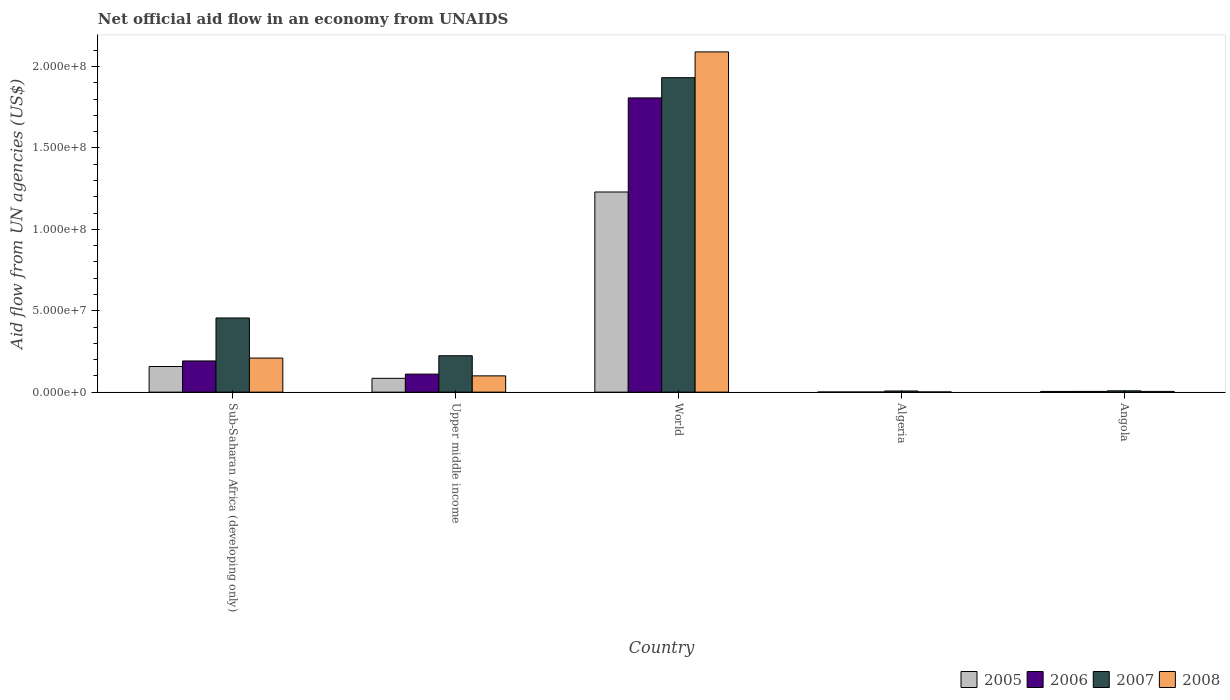How many different coloured bars are there?
Provide a short and direct response. 4. How many groups of bars are there?
Provide a succinct answer. 5. Are the number of bars per tick equal to the number of legend labels?
Keep it short and to the point. Yes. How many bars are there on the 2nd tick from the left?
Ensure brevity in your answer.  4. How many bars are there on the 4th tick from the right?
Provide a short and direct response. 4. What is the label of the 3rd group of bars from the left?
Ensure brevity in your answer.  World. In how many cases, is the number of bars for a given country not equal to the number of legend labels?
Offer a terse response. 0. What is the net official aid flow in 2006 in Sub-Saharan Africa (developing only)?
Ensure brevity in your answer.  1.92e+07. Across all countries, what is the maximum net official aid flow in 2007?
Give a very brief answer. 1.93e+08. In which country was the net official aid flow in 2006 minimum?
Make the answer very short. Algeria. What is the total net official aid flow in 2008 in the graph?
Offer a very short reply. 2.40e+08. What is the difference between the net official aid flow in 2007 in Algeria and that in Upper middle income?
Your answer should be compact. -2.16e+07. What is the difference between the net official aid flow in 2006 in Algeria and the net official aid flow in 2007 in Upper middle income?
Ensure brevity in your answer.  -2.23e+07. What is the average net official aid flow in 2006 per country?
Provide a short and direct response. 4.23e+07. What is the difference between the net official aid flow of/in 2005 and net official aid flow of/in 2007 in Angola?
Ensure brevity in your answer.  -3.80e+05. In how many countries, is the net official aid flow in 2005 greater than 200000000 US$?
Offer a terse response. 0. What is the ratio of the net official aid flow in 2007 in Sub-Saharan Africa (developing only) to that in World?
Make the answer very short. 0.24. What is the difference between the highest and the second highest net official aid flow in 2005?
Your answer should be very brief. 1.14e+08. What is the difference between the highest and the lowest net official aid flow in 2008?
Give a very brief answer. 2.09e+08. Is it the case that in every country, the sum of the net official aid flow in 2008 and net official aid flow in 2006 is greater than the sum of net official aid flow in 2007 and net official aid flow in 2005?
Ensure brevity in your answer.  No. How many bars are there?
Keep it short and to the point. 20. Are all the bars in the graph horizontal?
Your answer should be very brief. No. How many countries are there in the graph?
Provide a succinct answer. 5. Are the values on the major ticks of Y-axis written in scientific E-notation?
Give a very brief answer. Yes. Does the graph contain grids?
Your answer should be very brief. No. Where does the legend appear in the graph?
Keep it short and to the point. Bottom right. How are the legend labels stacked?
Provide a succinct answer. Horizontal. What is the title of the graph?
Ensure brevity in your answer.  Net official aid flow in an economy from UNAIDS. What is the label or title of the X-axis?
Provide a succinct answer. Country. What is the label or title of the Y-axis?
Provide a succinct answer. Aid flow from UN agencies (US$). What is the Aid flow from UN agencies (US$) of 2005 in Sub-Saharan Africa (developing only)?
Keep it short and to the point. 1.58e+07. What is the Aid flow from UN agencies (US$) of 2006 in Sub-Saharan Africa (developing only)?
Make the answer very short. 1.92e+07. What is the Aid flow from UN agencies (US$) in 2007 in Sub-Saharan Africa (developing only)?
Your answer should be compact. 4.56e+07. What is the Aid flow from UN agencies (US$) of 2008 in Sub-Saharan Africa (developing only)?
Offer a very short reply. 2.09e+07. What is the Aid flow from UN agencies (US$) of 2005 in Upper middle income?
Keep it short and to the point. 8.49e+06. What is the Aid flow from UN agencies (US$) in 2006 in Upper middle income?
Your answer should be very brief. 1.11e+07. What is the Aid flow from UN agencies (US$) in 2007 in Upper middle income?
Make the answer very short. 2.24e+07. What is the Aid flow from UN agencies (US$) in 2008 in Upper middle income?
Make the answer very short. 1.00e+07. What is the Aid flow from UN agencies (US$) of 2005 in World?
Give a very brief answer. 1.23e+08. What is the Aid flow from UN agencies (US$) of 2006 in World?
Offer a terse response. 1.81e+08. What is the Aid flow from UN agencies (US$) in 2007 in World?
Provide a short and direct response. 1.93e+08. What is the Aid flow from UN agencies (US$) of 2008 in World?
Provide a short and direct response. 2.09e+08. What is the Aid flow from UN agencies (US$) in 2005 in Algeria?
Your answer should be very brief. 9.00e+04. What is the Aid flow from UN agencies (US$) of 2007 in Algeria?
Keep it short and to the point. 7.10e+05. What is the Aid flow from UN agencies (US$) of 2005 in Angola?
Give a very brief answer. 4.30e+05. What is the Aid flow from UN agencies (US$) in 2007 in Angola?
Offer a very short reply. 8.10e+05. What is the Aid flow from UN agencies (US$) in 2008 in Angola?
Your response must be concise. 4.60e+05. Across all countries, what is the maximum Aid flow from UN agencies (US$) of 2005?
Provide a short and direct response. 1.23e+08. Across all countries, what is the maximum Aid flow from UN agencies (US$) in 2006?
Offer a terse response. 1.81e+08. Across all countries, what is the maximum Aid flow from UN agencies (US$) in 2007?
Your response must be concise. 1.93e+08. Across all countries, what is the maximum Aid flow from UN agencies (US$) in 2008?
Make the answer very short. 2.09e+08. Across all countries, what is the minimum Aid flow from UN agencies (US$) in 2006?
Offer a terse response. 9.00e+04. Across all countries, what is the minimum Aid flow from UN agencies (US$) in 2007?
Provide a short and direct response. 7.10e+05. What is the total Aid flow from UN agencies (US$) in 2005 in the graph?
Give a very brief answer. 1.48e+08. What is the total Aid flow from UN agencies (US$) of 2006 in the graph?
Provide a short and direct response. 2.11e+08. What is the total Aid flow from UN agencies (US$) in 2007 in the graph?
Your response must be concise. 2.63e+08. What is the total Aid flow from UN agencies (US$) of 2008 in the graph?
Provide a short and direct response. 2.40e+08. What is the difference between the Aid flow from UN agencies (US$) in 2005 in Sub-Saharan Africa (developing only) and that in Upper middle income?
Provide a succinct answer. 7.26e+06. What is the difference between the Aid flow from UN agencies (US$) of 2006 in Sub-Saharan Africa (developing only) and that in Upper middle income?
Your response must be concise. 8.08e+06. What is the difference between the Aid flow from UN agencies (US$) of 2007 in Sub-Saharan Africa (developing only) and that in Upper middle income?
Provide a short and direct response. 2.32e+07. What is the difference between the Aid flow from UN agencies (US$) in 2008 in Sub-Saharan Africa (developing only) and that in Upper middle income?
Your answer should be compact. 1.09e+07. What is the difference between the Aid flow from UN agencies (US$) of 2005 in Sub-Saharan Africa (developing only) and that in World?
Your response must be concise. -1.07e+08. What is the difference between the Aid flow from UN agencies (US$) of 2006 in Sub-Saharan Africa (developing only) and that in World?
Offer a very short reply. -1.62e+08. What is the difference between the Aid flow from UN agencies (US$) in 2007 in Sub-Saharan Africa (developing only) and that in World?
Give a very brief answer. -1.48e+08. What is the difference between the Aid flow from UN agencies (US$) of 2008 in Sub-Saharan Africa (developing only) and that in World?
Give a very brief answer. -1.88e+08. What is the difference between the Aid flow from UN agencies (US$) in 2005 in Sub-Saharan Africa (developing only) and that in Algeria?
Offer a terse response. 1.57e+07. What is the difference between the Aid flow from UN agencies (US$) of 2006 in Sub-Saharan Africa (developing only) and that in Algeria?
Your answer should be compact. 1.91e+07. What is the difference between the Aid flow from UN agencies (US$) of 2007 in Sub-Saharan Africa (developing only) and that in Algeria?
Your response must be concise. 4.48e+07. What is the difference between the Aid flow from UN agencies (US$) in 2008 in Sub-Saharan Africa (developing only) and that in Algeria?
Provide a succinct answer. 2.08e+07. What is the difference between the Aid flow from UN agencies (US$) in 2005 in Sub-Saharan Africa (developing only) and that in Angola?
Your answer should be compact. 1.53e+07. What is the difference between the Aid flow from UN agencies (US$) of 2006 in Sub-Saharan Africa (developing only) and that in Angola?
Your answer should be compact. 1.87e+07. What is the difference between the Aid flow from UN agencies (US$) of 2007 in Sub-Saharan Africa (developing only) and that in Angola?
Provide a succinct answer. 4.47e+07. What is the difference between the Aid flow from UN agencies (US$) in 2008 in Sub-Saharan Africa (developing only) and that in Angola?
Offer a very short reply. 2.05e+07. What is the difference between the Aid flow from UN agencies (US$) in 2005 in Upper middle income and that in World?
Your response must be concise. -1.14e+08. What is the difference between the Aid flow from UN agencies (US$) of 2006 in Upper middle income and that in World?
Your answer should be compact. -1.70e+08. What is the difference between the Aid flow from UN agencies (US$) in 2007 in Upper middle income and that in World?
Provide a succinct answer. -1.71e+08. What is the difference between the Aid flow from UN agencies (US$) in 2008 in Upper middle income and that in World?
Make the answer very short. -1.99e+08. What is the difference between the Aid flow from UN agencies (US$) in 2005 in Upper middle income and that in Algeria?
Offer a very short reply. 8.40e+06. What is the difference between the Aid flow from UN agencies (US$) of 2006 in Upper middle income and that in Algeria?
Your answer should be compact. 1.10e+07. What is the difference between the Aid flow from UN agencies (US$) of 2007 in Upper middle income and that in Algeria?
Your response must be concise. 2.16e+07. What is the difference between the Aid flow from UN agencies (US$) of 2008 in Upper middle income and that in Algeria?
Offer a very short reply. 9.87e+06. What is the difference between the Aid flow from UN agencies (US$) of 2005 in Upper middle income and that in Angola?
Your answer should be compact. 8.06e+06. What is the difference between the Aid flow from UN agencies (US$) of 2006 in Upper middle income and that in Angola?
Make the answer very short. 1.06e+07. What is the difference between the Aid flow from UN agencies (US$) of 2007 in Upper middle income and that in Angola?
Your answer should be compact. 2.16e+07. What is the difference between the Aid flow from UN agencies (US$) of 2008 in Upper middle income and that in Angola?
Provide a succinct answer. 9.54e+06. What is the difference between the Aid flow from UN agencies (US$) in 2005 in World and that in Algeria?
Your answer should be very brief. 1.23e+08. What is the difference between the Aid flow from UN agencies (US$) in 2006 in World and that in Algeria?
Ensure brevity in your answer.  1.81e+08. What is the difference between the Aid flow from UN agencies (US$) in 2007 in World and that in Algeria?
Offer a terse response. 1.92e+08. What is the difference between the Aid flow from UN agencies (US$) in 2008 in World and that in Algeria?
Give a very brief answer. 2.09e+08. What is the difference between the Aid flow from UN agencies (US$) of 2005 in World and that in Angola?
Offer a terse response. 1.22e+08. What is the difference between the Aid flow from UN agencies (US$) of 2006 in World and that in Angola?
Provide a succinct answer. 1.80e+08. What is the difference between the Aid flow from UN agencies (US$) of 2007 in World and that in Angola?
Make the answer very short. 1.92e+08. What is the difference between the Aid flow from UN agencies (US$) in 2008 in World and that in Angola?
Make the answer very short. 2.08e+08. What is the difference between the Aid flow from UN agencies (US$) in 2006 in Algeria and that in Angola?
Offer a very short reply. -3.60e+05. What is the difference between the Aid flow from UN agencies (US$) of 2008 in Algeria and that in Angola?
Your answer should be very brief. -3.30e+05. What is the difference between the Aid flow from UN agencies (US$) of 2005 in Sub-Saharan Africa (developing only) and the Aid flow from UN agencies (US$) of 2006 in Upper middle income?
Your answer should be very brief. 4.67e+06. What is the difference between the Aid flow from UN agencies (US$) in 2005 in Sub-Saharan Africa (developing only) and the Aid flow from UN agencies (US$) in 2007 in Upper middle income?
Your response must be concise. -6.61e+06. What is the difference between the Aid flow from UN agencies (US$) in 2005 in Sub-Saharan Africa (developing only) and the Aid flow from UN agencies (US$) in 2008 in Upper middle income?
Provide a succinct answer. 5.75e+06. What is the difference between the Aid flow from UN agencies (US$) in 2006 in Sub-Saharan Africa (developing only) and the Aid flow from UN agencies (US$) in 2007 in Upper middle income?
Offer a terse response. -3.20e+06. What is the difference between the Aid flow from UN agencies (US$) in 2006 in Sub-Saharan Africa (developing only) and the Aid flow from UN agencies (US$) in 2008 in Upper middle income?
Make the answer very short. 9.16e+06. What is the difference between the Aid flow from UN agencies (US$) of 2007 in Sub-Saharan Africa (developing only) and the Aid flow from UN agencies (US$) of 2008 in Upper middle income?
Your answer should be compact. 3.56e+07. What is the difference between the Aid flow from UN agencies (US$) in 2005 in Sub-Saharan Africa (developing only) and the Aid flow from UN agencies (US$) in 2006 in World?
Provide a short and direct response. -1.65e+08. What is the difference between the Aid flow from UN agencies (US$) in 2005 in Sub-Saharan Africa (developing only) and the Aid flow from UN agencies (US$) in 2007 in World?
Your response must be concise. -1.77e+08. What is the difference between the Aid flow from UN agencies (US$) in 2005 in Sub-Saharan Africa (developing only) and the Aid flow from UN agencies (US$) in 2008 in World?
Make the answer very short. -1.93e+08. What is the difference between the Aid flow from UN agencies (US$) of 2006 in Sub-Saharan Africa (developing only) and the Aid flow from UN agencies (US$) of 2007 in World?
Offer a terse response. -1.74e+08. What is the difference between the Aid flow from UN agencies (US$) of 2006 in Sub-Saharan Africa (developing only) and the Aid flow from UN agencies (US$) of 2008 in World?
Provide a short and direct response. -1.90e+08. What is the difference between the Aid flow from UN agencies (US$) of 2007 in Sub-Saharan Africa (developing only) and the Aid flow from UN agencies (US$) of 2008 in World?
Keep it short and to the point. -1.63e+08. What is the difference between the Aid flow from UN agencies (US$) of 2005 in Sub-Saharan Africa (developing only) and the Aid flow from UN agencies (US$) of 2006 in Algeria?
Offer a very short reply. 1.57e+07. What is the difference between the Aid flow from UN agencies (US$) of 2005 in Sub-Saharan Africa (developing only) and the Aid flow from UN agencies (US$) of 2007 in Algeria?
Your answer should be compact. 1.50e+07. What is the difference between the Aid flow from UN agencies (US$) of 2005 in Sub-Saharan Africa (developing only) and the Aid flow from UN agencies (US$) of 2008 in Algeria?
Give a very brief answer. 1.56e+07. What is the difference between the Aid flow from UN agencies (US$) in 2006 in Sub-Saharan Africa (developing only) and the Aid flow from UN agencies (US$) in 2007 in Algeria?
Offer a very short reply. 1.84e+07. What is the difference between the Aid flow from UN agencies (US$) of 2006 in Sub-Saharan Africa (developing only) and the Aid flow from UN agencies (US$) of 2008 in Algeria?
Give a very brief answer. 1.90e+07. What is the difference between the Aid flow from UN agencies (US$) in 2007 in Sub-Saharan Africa (developing only) and the Aid flow from UN agencies (US$) in 2008 in Algeria?
Ensure brevity in your answer.  4.54e+07. What is the difference between the Aid flow from UN agencies (US$) of 2005 in Sub-Saharan Africa (developing only) and the Aid flow from UN agencies (US$) of 2006 in Angola?
Provide a short and direct response. 1.53e+07. What is the difference between the Aid flow from UN agencies (US$) of 2005 in Sub-Saharan Africa (developing only) and the Aid flow from UN agencies (US$) of 2007 in Angola?
Provide a short and direct response. 1.49e+07. What is the difference between the Aid flow from UN agencies (US$) in 2005 in Sub-Saharan Africa (developing only) and the Aid flow from UN agencies (US$) in 2008 in Angola?
Provide a succinct answer. 1.53e+07. What is the difference between the Aid flow from UN agencies (US$) in 2006 in Sub-Saharan Africa (developing only) and the Aid flow from UN agencies (US$) in 2007 in Angola?
Offer a very short reply. 1.84e+07. What is the difference between the Aid flow from UN agencies (US$) in 2006 in Sub-Saharan Africa (developing only) and the Aid flow from UN agencies (US$) in 2008 in Angola?
Make the answer very short. 1.87e+07. What is the difference between the Aid flow from UN agencies (US$) of 2007 in Sub-Saharan Africa (developing only) and the Aid flow from UN agencies (US$) of 2008 in Angola?
Give a very brief answer. 4.51e+07. What is the difference between the Aid flow from UN agencies (US$) in 2005 in Upper middle income and the Aid flow from UN agencies (US$) in 2006 in World?
Your answer should be compact. -1.72e+08. What is the difference between the Aid flow from UN agencies (US$) in 2005 in Upper middle income and the Aid flow from UN agencies (US$) in 2007 in World?
Offer a very short reply. -1.85e+08. What is the difference between the Aid flow from UN agencies (US$) in 2005 in Upper middle income and the Aid flow from UN agencies (US$) in 2008 in World?
Ensure brevity in your answer.  -2.00e+08. What is the difference between the Aid flow from UN agencies (US$) of 2006 in Upper middle income and the Aid flow from UN agencies (US$) of 2007 in World?
Give a very brief answer. -1.82e+08. What is the difference between the Aid flow from UN agencies (US$) of 2006 in Upper middle income and the Aid flow from UN agencies (US$) of 2008 in World?
Make the answer very short. -1.98e+08. What is the difference between the Aid flow from UN agencies (US$) of 2007 in Upper middle income and the Aid flow from UN agencies (US$) of 2008 in World?
Keep it short and to the point. -1.87e+08. What is the difference between the Aid flow from UN agencies (US$) in 2005 in Upper middle income and the Aid flow from UN agencies (US$) in 2006 in Algeria?
Make the answer very short. 8.40e+06. What is the difference between the Aid flow from UN agencies (US$) in 2005 in Upper middle income and the Aid flow from UN agencies (US$) in 2007 in Algeria?
Your answer should be compact. 7.78e+06. What is the difference between the Aid flow from UN agencies (US$) in 2005 in Upper middle income and the Aid flow from UN agencies (US$) in 2008 in Algeria?
Your answer should be compact. 8.36e+06. What is the difference between the Aid flow from UN agencies (US$) of 2006 in Upper middle income and the Aid flow from UN agencies (US$) of 2007 in Algeria?
Your answer should be compact. 1.04e+07. What is the difference between the Aid flow from UN agencies (US$) in 2006 in Upper middle income and the Aid flow from UN agencies (US$) in 2008 in Algeria?
Your answer should be very brief. 1.10e+07. What is the difference between the Aid flow from UN agencies (US$) in 2007 in Upper middle income and the Aid flow from UN agencies (US$) in 2008 in Algeria?
Provide a short and direct response. 2.22e+07. What is the difference between the Aid flow from UN agencies (US$) in 2005 in Upper middle income and the Aid flow from UN agencies (US$) in 2006 in Angola?
Make the answer very short. 8.04e+06. What is the difference between the Aid flow from UN agencies (US$) of 2005 in Upper middle income and the Aid flow from UN agencies (US$) of 2007 in Angola?
Your answer should be very brief. 7.68e+06. What is the difference between the Aid flow from UN agencies (US$) in 2005 in Upper middle income and the Aid flow from UN agencies (US$) in 2008 in Angola?
Ensure brevity in your answer.  8.03e+06. What is the difference between the Aid flow from UN agencies (US$) in 2006 in Upper middle income and the Aid flow from UN agencies (US$) in 2007 in Angola?
Provide a short and direct response. 1.03e+07. What is the difference between the Aid flow from UN agencies (US$) of 2006 in Upper middle income and the Aid flow from UN agencies (US$) of 2008 in Angola?
Ensure brevity in your answer.  1.06e+07. What is the difference between the Aid flow from UN agencies (US$) in 2007 in Upper middle income and the Aid flow from UN agencies (US$) in 2008 in Angola?
Make the answer very short. 2.19e+07. What is the difference between the Aid flow from UN agencies (US$) in 2005 in World and the Aid flow from UN agencies (US$) in 2006 in Algeria?
Your answer should be very brief. 1.23e+08. What is the difference between the Aid flow from UN agencies (US$) in 2005 in World and the Aid flow from UN agencies (US$) in 2007 in Algeria?
Offer a very short reply. 1.22e+08. What is the difference between the Aid flow from UN agencies (US$) in 2005 in World and the Aid flow from UN agencies (US$) in 2008 in Algeria?
Offer a very short reply. 1.23e+08. What is the difference between the Aid flow from UN agencies (US$) of 2006 in World and the Aid flow from UN agencies (US$) of 2007 in Algeria?
Your answer should be very brief. 1.80e+08. What is the difference between the Aid flow from UN agencies (US$) in 2006 in World and the Aid flow from UN agencies (US$) in 2008 in Algeria?
Provide a succinct answer. 1.81e+08. What is the difference between the Aid flow from UN agencies (US$) of 2007 in World and the Aid flow from UN agencies (US$) of 2008 in Algeria?
Offer a very short reply. 1.93e+08. What is the difference between the Aid flow from UN agencies (US$) of 2005 in World and the Aid flow from UN agencies (US$) of 2006 in Angola?
Provide a succinct answer. 1.22e+08. What is the difference between the Aid flow from UN agencies (US$) in 2005 in World and the Aid flow from UN agencies (US$) in 2007 in Angola?
Provide a short and direct response. 1.22e+08. What is the difference between the Aid flow from UN agencies (US$) in 2005 in World and the Aid flow from UN agencies (US$) in 2008 in Angola?
Your answer should be very brief. 1.22e+08. What is the difference between the Aid flow from UN agencies (US$) in 2006 in World and the Aid flow from UN agencies (US$) in 2007 in Angola?
Offer a terse response. 1.80e+08. What is the difference between the Aid flow from UN agencies (US$) of 2006 in World and the Aid flow from UN agencies (US$) of 2008 in Angola?
Ensure brevity in your answer.  1.80e+08. What is the difference between the Aid flow from UN agencies (US$) in 2007 in World and the Aid flow from UN agencies (US$) in 2008 in Angola?
Provide a short and direct response. 1.93e+08. What is the difference between the Aid flow from UN agencies (US$) of 2005 in Algeria and the Aid flow from UN agencies (US$) of 2006 in Angola?
Give a very brief answer. -3.60e+05. What is the difference between the Aid flow from UN agencies (US$) of 2005 in Algeria and the Aid flow from UN agencies (US$) of 2007 in Angola?
Make the answer very short. -7.20e+05. What is the difference between the Aid flow from UN agencies (US$) of 2005 in Algeria and the Aid flow from UN agencies (US$) of 2008 in Angola?
Keep it short and to the point. -3.70e+05. What is the difference between the Aid flow from UN agencies (US$) in 2006 in Algeria and the Aid flow from UN agencies (US$) in 2007 in Angola?
Your response must be concise. -7.20e+05. What is the difference between the Aid flow from UN agencies (US$) of 2006 in Algeria and the Aid flow from UN agencies (US$) of 2008 in Angola?
Provide a short and direct response. -3.70e+05. What is the difference between the Aid flow from UN agencies (US$) in 2007 in Algeria and the Aid flow from UN agencies (US$) in 2008 in Angola?
Provide a succinct answer. 2.50e+05. What is the average Aid flow from UN agencies (US$) in 2005 per country?
Provide a succinct answer. 2.95e+07. What is the average Aid flow from UN agencies (US$) in 2006 per country?
Offer a terse response. 4.23e+07. What is the average Aid flow from UN agencies (US$) of 2007 per country?
Your answer should be compact. 5.25e+07. What is the average Aid flow from UN agencies (US$) of 2008 per country?
Provide a succinct answer. 4.81e+07. What is the difference between the Aid flow from UN agencies (US$) of 2005 and Aid flow from UN agencies (US$) of 2006 in Sub-Saharan Africa (developing only)?
Your response must be concise. -3.41e+06. What is the difference between the Aid flow from UN agencies (US$) in 2005 and Aid flow from UN agencies (US$) in 2007 in Sub-Saharan Africa (developing only)?
Offer a very short reply. -2.98e+07. What is the difference between the Aid flow from UN agencies (US$) in 2005 and Aid flow from UN agencies (US$) in 2008 in Sub-Saharan Africa (developing only)?
Offer a terse response. -5.18e+06. What is the difference between the Aid flow from UN agencies (US$) of 2006 and Aid flow from UN agencies (US$) of 2007 in Sub-Saharan Africa (developing only)?
Make the answer very short. -2.64e+07. What is the difference between the Aid flow from UN agencies (US$) in 2006 and Aid flow from UN agencies (US$) in 2008 in Sub-Saharan Africa (developing only)?
Provide a short and direct response. -1.77e+06. What is the difference between the Aid flow from UN agencies (US$) in 2007 and Aid flow from UN agencies (US$) in 2008 in Sub-Saharan Africa (developing only)?
Give a very brief answer. 2.46e+07. What is the difference between the Aid flow from UN agencies (US$) in 2005 and Aid flow from UN agencies (US$) in 2006 in Upper middle income?
Provide a short and direct response. -2.59e+06. What is the difference between the Aid flow from UN agencies (US$) of 2005 and Aid flow from UN agencies (US$) of 2007 in Upper middle income?
Provide a short and direct response. -1.39e+07. What is the difference between the Aid flow from UN agencies (US$) in 2005 and Aid flow from UN agencies (US$) in 2008 in Upper middle income?
Ensure brevity in your answer.  -1.51e+06. What is the difference between the Aid flow from UN agencies (US$) of 2006 and Aid flow from UN agencies (US$) of 2007 in Upper middle income?
Ensure brevity in your answer.  -1.13e+07. What is the difference between the Aid flow from UN agencies (US$) of 2006 and Aid flow from UN agencies (US$) of 2008 in Upper middle income?
Give a very brief answer. 1.08e+06. What is the difference between the Aid flow from UN agencies (US$) of 2007 and Aid flow from UN agencies (US$) of 2008 in Upper middle income?
Your answer should be compact. 1.24e+07. What is the difference between the Aid flow from UN agencies (US$) of 2005 and Aid flow from UN agencies (US$) of 2006 in World?
Provide a succinct answer. -5.78e+07. What is the difference between the Aid flow from UN agencies (US$) in 2005 and Aid flow from UN agencies (US$) in 2007 in World?
Provide a short and direct response. -7.02e+07. What is the difference between the Aid flow from UN agencies (US$) of 2005 and Aid flow from UN agencies (US$) of 2008 in World?
Your answer should be compact. -8.60e+07. What is the difference between the Aid flow from UN agencies (US$) of 2006 and Aid flow from UN agencies (US$) of 2007 in World?
Give a very brief answer. -1.24e+07. What is the difference between the Aid flow from UN agencies (US$) of 2006 and Aid flow from UN agencies (US$) of 2008 in World?
Ensure brevity in your answer.  -2.83e+07. What is the difference between the Aid flow from UN agencies (US$) in 2007 and Aid flow from UN agencies (US$) in 2008 in World?
Provide a succinct answer. -1.58e+07. What is the difference between the Aid flow from UN agencies (US$) of 2005 and Aid flow from UN agencies (US$) of 2007 in Algeria?
Your response must be concise. -6.20e+05. What is the difference between the Aid flow from UN agencies (US$) in 2006 and Aid flow from UN agencies (US$) in 2007 in Algeria?
Your answer should be compact. -6.20e+05. What is the difference between the Aid flow from UN agencies (US$) of 2007 and Aid flow from UN agencies (US$) of 2008 in Algeria?
Your answer should be compact. 5.80e+05. What is the difference between the Aid flow from UN agencies (US$) in 2005 and Aid flow from UN agencies (US$) in 2006 in Angola?
Your answer should be compact. -2.00e+04. What is the difference between the Aid flow from UN agencies (US$) of 2005 and Aid flow from UN agencies (US$) of 2007 in Angola?
Keep it short and to the point. -3.80e+05. What is the difference between the Aid flow from UN agencies (US$) in 2006 and Aid flow from UN agencies (US$) in 2007 in Angola?
Give a very brief answer. -3.60e+05. What is the ratio of the Aid flow from UN agencies (US$) of 2005 in Sub-Saharan Africa (developing only) to that in Upper middle income?
Offer a terse response. 1.86. What is the ratio of the Aid flow from UN agencies (US$) in 2006 in Sub-Saharan Africa (developing only) to that in Upper middle income?
Make the answer very short. 1.73. What is the ratio of the Aid flow from UN agencies (US$) in 2007 in Sub-Saharan Africa (developing only) to that in Upper middle income?
Give a very brief answer. 2.04. What is the ratio of the Aid flow from UN agencies (US$) in 2008 in Sub-Saharan Africa (developing only) to that in Upper middle income?
Provide a succinct answer. 2.09. What is the ratio of the Aid flow from UN agencies (US$) of 2005 in Sub-Saharan Africa (developing only) to that in World?
Make the answer very short. 0.13. What is the ratio of the Aid flow from UN agencies (US$) of 2006 in Sub-Saharan Africa (developing only) to that in World?
Make the answer very short. 0.11. What is the ratio of the Aid flow from UN agencies (US$) of 2007 in Sub-Saharan Africa (developing only) to that in World?
Give a very brief answer. 0.24. What is the ratio of the Aid flow from UN agencies (US$) in 2008 in Sub-Saharan Africa (developing only) to that in World?
Provide a succinct answer. 0.1. What is the ratio of the Aid flow from UN agencies (US$) in 2005 in Sub-Saharan Africa (developing only) to that in Algeria?
Make the answer very short. 175. What is the ratio of the Aid flow from UN agencies (US$) in 2006 in Sub-Saharan Africa (developing only) to that in Algeria?
Your response must be concise. 212.89. What is the ratio of the Aid flow from UN agencies (US$) in 2007 in Sub-Saharan Africa (developing only) to that in Algeria?
Provide a short and direct response. 64.15. What is the ratio of the Aid flow from UN agencies (US$) in 2008 in Sub-Saharan Africa (developing only) to that in Algeria?
Offer a terse response. 161. What is the ratio of the Aid flow from UN agencies (US$) of 2005 in Sub-Saharan Africa (developing only) to that in Angola?
Provide a succinct answer. 36.63. What is the ratio of the Aid flow from UN agencies (US$) of 2006 in Sub-Saharan Africa (developing only) to that in Angola?
Your answer should be very brief. 42.58. What is the ratio of the Aid flow from UN agencies (US$) of 2007 in Sub-Saharan Africa (developing only) to that in Angola?
Make the answer very short. 56.23. What is the ratio of the Aid flow from UN agencies (US$) in 2008 in Sub-Saharan Africa (developing only) to that in Angola?
Your response must be concise. 45.5. What is the ratio of the Aid flow from UN agencies (US$) of 2005 in Upper middle income to that in World?
Keep it short and to the point. 0.07. What is the ratio of the Aid flow from UN agencies (US$) in 2006 in Upper middle income to that in World?
Ensure brevity in your answer.  0.06. What is the ratio of the Aid flow from UN agencies (US$) of 2007 in Upper middle income to that in World?
Make the answer very short. 0.12. What is the ratio of the Aid flow from UN agencies (US$) of 2008 in Upper middle income to that in World?
Offer a terse response. 0.05. What is the ratio of the Aid flow from UN agencies (US$) of 2005 in Upper middle income to that in Algeria?
Provide a short and direct response. 94.33. What is the ratio of the Aid flow from UN agencies (US$) in 2006 in Upper middle income to that in Algeria?
Keep it short and to the point. 123.11. What is the ratio of the Aid flow from UN agencies (US$) in 2007 in Upper middle income to that in Algeria?
Make the answer very short. 31.49. What is the ratio of the Aid flow from UN agencies (US$) of 2008 in Upper middle income to that in Algeria?
Provide a short and direct response. 76.92. What is the ratio of the Aid flow from UN agencies (US$) of 2005 in Upper middle income to that in Angola?
Offer a very short reply. 19.74. What is the ratio of the Aid flow from UN agencies (US$) in 2006 in Upper middle income to that in Angola?
Ensure brevity in your answer.  24.62. What is the ratio of the Aid flow from UN agencies (US$) in 2007 in Upper middle income to that in Angola?
Offer a very short reply. 27.6. What is the ratio of the Aid flow from UN agencies (US$) of 2008 in Upper middle income to that in Angola?
Offer a terse response. 21.74. What is the ratio of the Aid flow from UN agencies (US$) in 2005 in World to that in Algeria?
Keep it short and to the point. 1365.67. What is the ratio of the Aid flow from UN agencies (US$) of 2006 in World to that in Algeria?
Make the answer very short. 2007.67. What is the ratio of the Aid flow from UN agencies (US$) of 2007 in World to that in Algeria?
Give a very brief answer. 271.97. What is the ratio of the Aid flow from UN agencies (US$) in 2008 in World to that in Algeria?
Ensure brevity in your answer.  1607.31. What is the ratio of the Aid flow from UN agencies (US$) in 2005 in World to that in Angola?
Offer a very short reply. 285.84. What is the ratio of the Aid flow from UN agencies (US$) in 2006 in World to that in Angola?
Give a very brief answer. 401.53. What is the ratio of the Aid flow from UN agencies (US$) of 2007 in World to that in Angola?
Give a very brief answer. 238.4. What is the ratio of the Aid flow from UN agencies (US$) of 2008 in World to that in Angola?
Ensure brevity in your answer.  454.24. What is the ratio of the Aid flow from UN agencies (US$) of 2005 in Algeria to that in Angola?
Your answer should be very brief. 0.21. What is the ratio of the Aid flow from UN agencies (US$) in 2006 in Algeria to that in Angola?
Your answer should be compact. 0.2. What is the ratio of the Aid flow from UN agencies (US$) in 2007 in Algeria to that in Angola?
Your answer should be very brief. 0.88. What is the ratio of the Aid flow from UN agencies (US$) of 2008 in Algeria to that in Angola?
Offer a very short reply. 0.28. What is the difference between the highest and the second highest Aid flow from UN agencies (US$) of 2005?
Provide a short and direct response. 1.07e+08. What is the difference between the highest and the second highest Aid flow from UN agencies (US$) in 2006?
Offer a terse response. 1.62e+08. What is the difference between the highest and the second highest Aid flow from UN agencies (US$) in 2007?
Your answer should be compact. 1.48e+08. What is the difference between the highest and the second highest Aid flow from UN agencies (US$) in 2008?
Provide a succinct answer. 1.88e+08. What is the difference between the highest and the lowest Aid flow from UN agencies (US$) of 2005?
Offer a very short reply. 1.23e+08. What is the difference between the highest and the lowest Aid flow from UN agencies (US$) of 2006?
Provide a short and direct response. 1.81e+08. What is the difference between the highest and the lowest Aid flow from UN agencies (US$) in 2007?
Offer a very short reply. 1.92e+08. What is the difference between the highest and the lowest Aid flow from UN agencies (US$) in 2008?
Make the answer very short. 2.09e+08. 